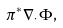Convert formula to latex. <formula><loc_0><loc_0><loc_500><loc_500>\pi ^ { * } \nabla _ { \cdot } \Phi ,</formula> 